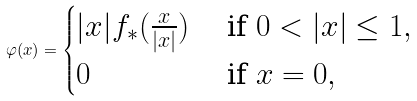<formula> <loc_0><loc_0><loc_500><loc_500>\varphi ( x ) = \begin{cases} | x | f _ { * } ( \frac { x } { | x | } ) & \text { if } 0 < | x | \leq 1 , \\ 0 & \text { if } x = 0 , \end{cases}</formula> 